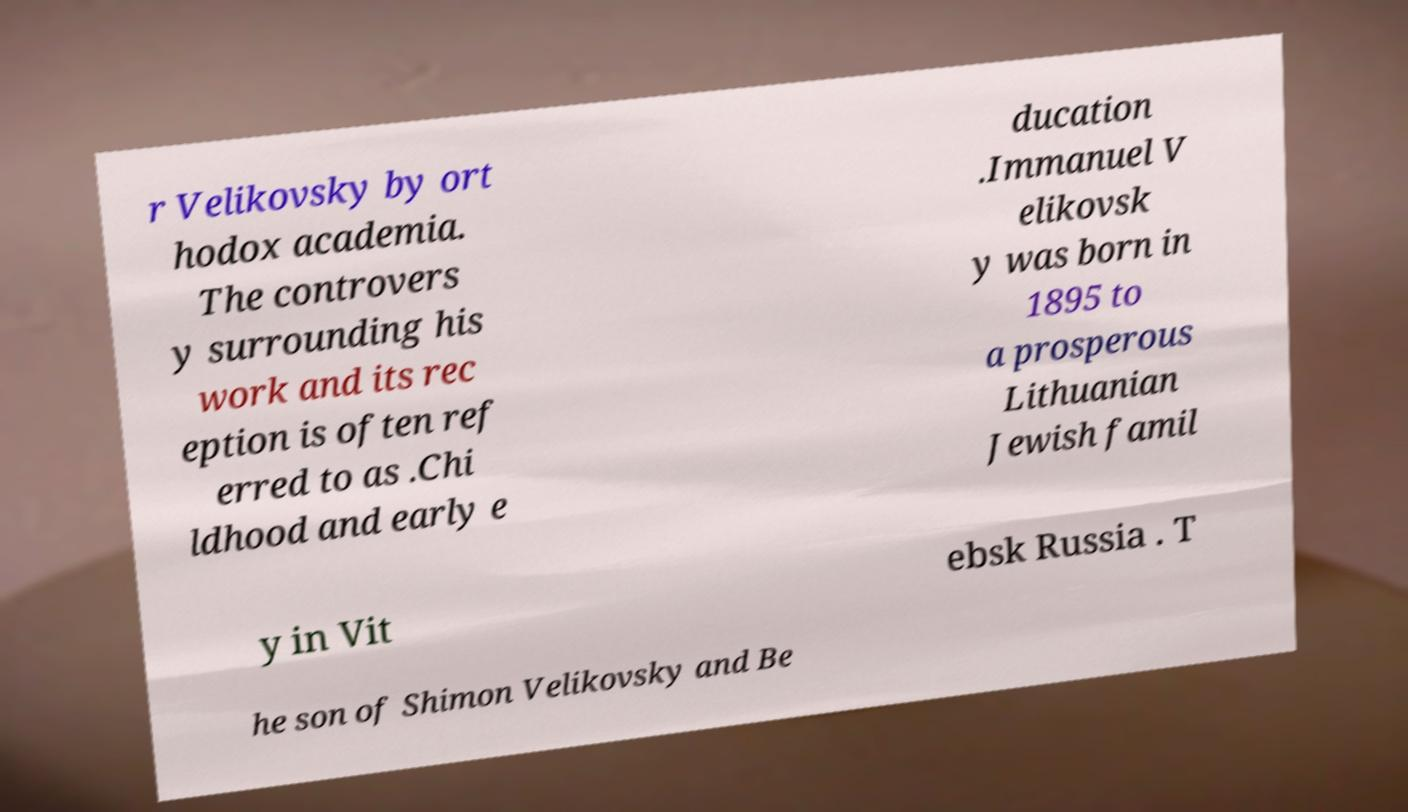I need the written content from this picture converted into text. Can you do that? r Velikovsky by ort hodox academia. The controvers y surrounding his work and its rec eption is often ref erred to as .Chi ldhood and early e ducation .Immanuel V elikovsk y was born in 1895 to a prosperous Lithuanian Jewish famil y in Vit ebsk Russia . T he son of Shimon Velikovsky and Be 